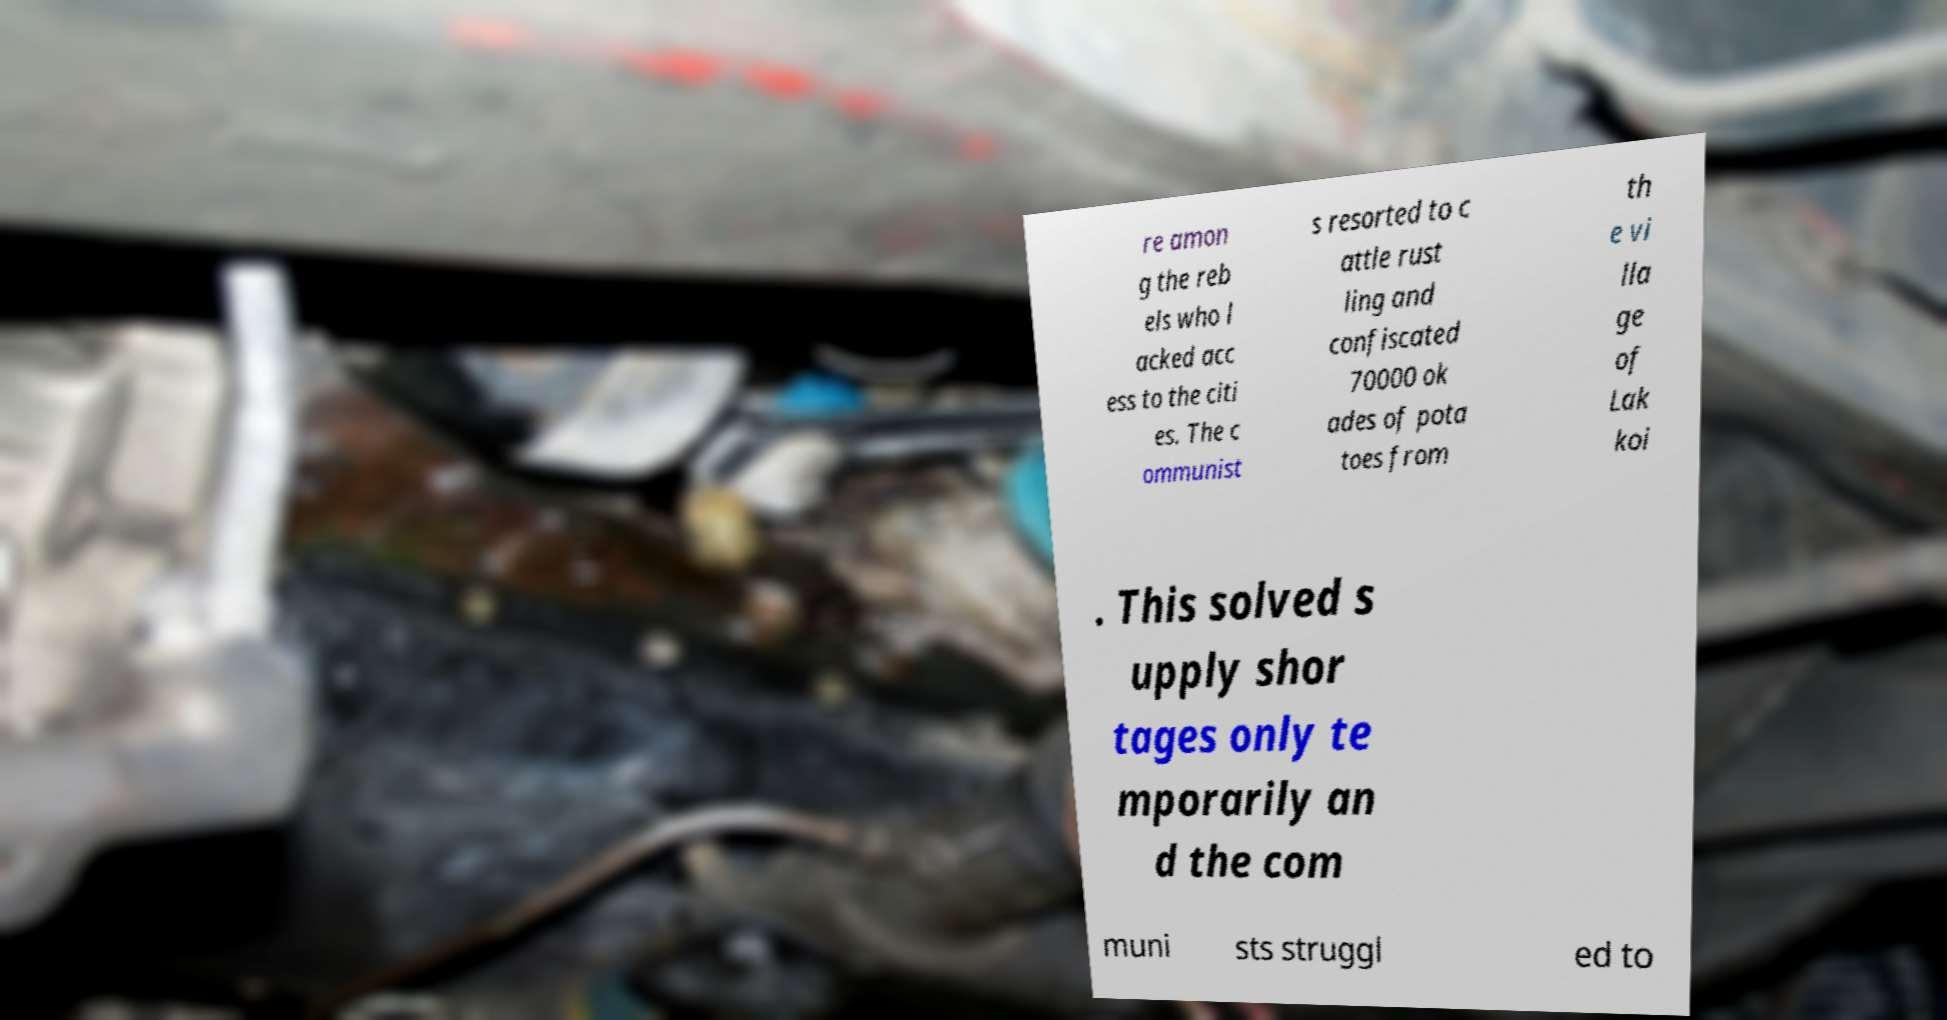For documentation purposes, I need the text within this image transcribed. Could you provide that? re amon g the reb els who l acked acc ess to the citi es. The c ommunist s resorted to c attle rust ling and confiscated 70000 ok ades of pota toes from th e vi lla ge of Lak koi . This solved s upply shor tages only te mporarily an d the com muni sts struggl ed to 